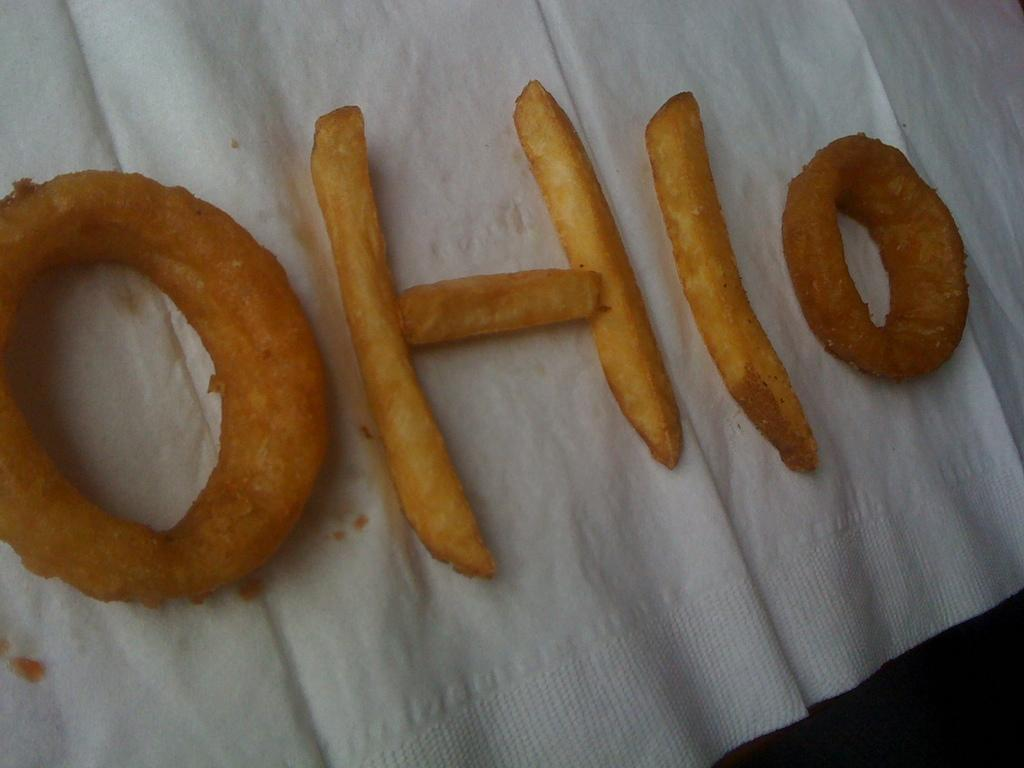What is the main feature of the cloth in the image? There is a white cloth in the image, and the main feature is a snake depicted on it. What is unique about the snake's shape on the cloth? The snake is shaped like the word "OHIO." What type of bag can be seen in the image? There is no bag present in the image; it features a white cloth with a snake shaped like the word "OHIO." 